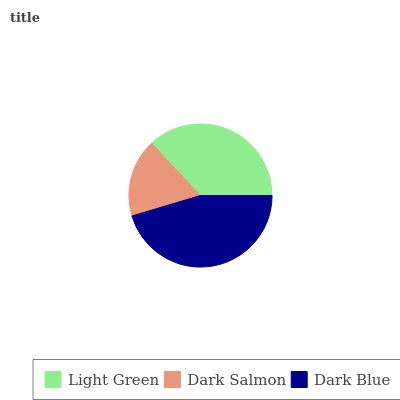Is Dark Salmon the minimum?
Answer yes or no. Yes. Is Dark Blue the maximum?
Answer yes or no. Yes. Is Dark Blue the minimum?
Answer yes or no. No. Is Dark Salmon the maximum?
Answer yes or no. No. Is Dark Blue greater than Dark Salmon?
Answer yes or no. Yes. Is Dark Salmon less than Dark Blue?
Answer yes or no. Yes. Is Dark Salmon greater than Dark Blue?
Answer yes or no. No. Is Dark Blue less than Dark Salmon?
Answer yes or no. No. Is Light Green the high median?
Answer yes or no. Yes. Is Light Green the low median?
Answer yes or no. Yes. Is Dark Salmon the high median?
Answer yes or no. No. Is Dark Blue the low median?
Answer yes or no. No. 